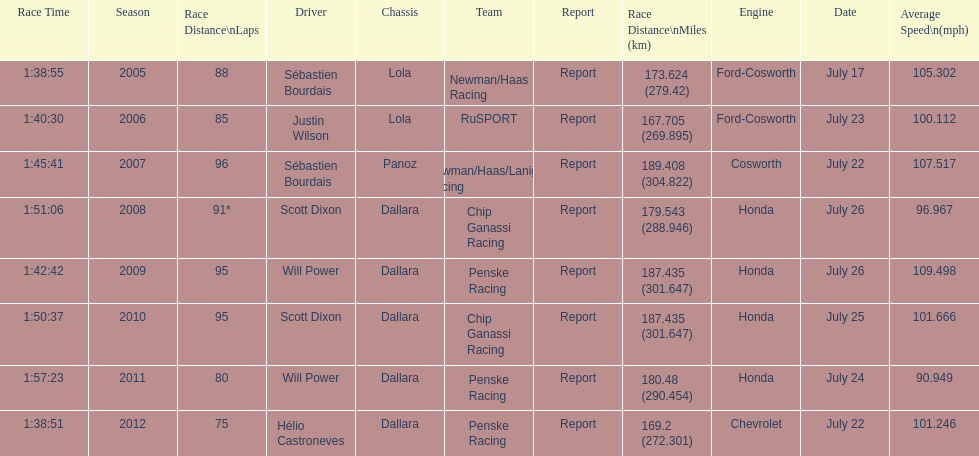How many different teams are represented in the table? 4. 